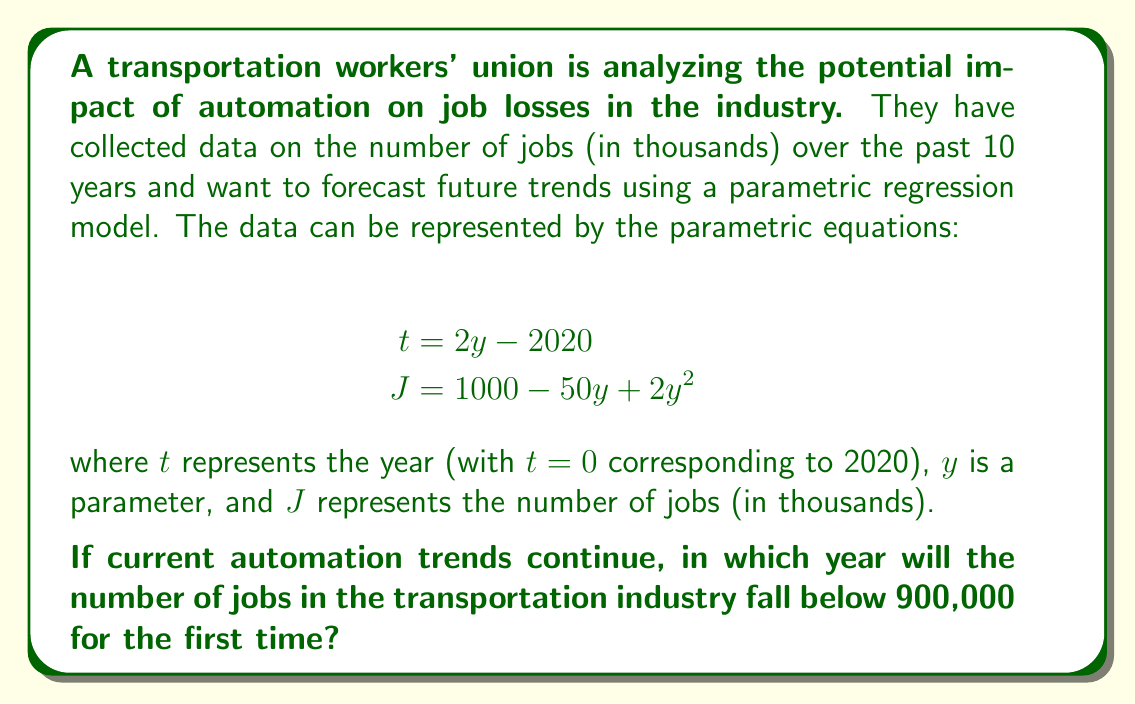Give your solution to this math problem. Let's approach this step-by-step:

1) We need to find when $J < 900$. So, we set up the inequality:
   $$1000 - 50y + 2y^2 < 900$$

2) Rearrange the inequality:
   $$2y^2 - 50y + 100 < 0$$

3) This is a quadratic inequality. To solve it, we first find the roots of the equation:
   $$2y^2 - 50y + 100 = 0$$

4) Using the quadratic formula $y = \frac{-b \pm \sqrt{b^2 - 4ac}}{2a}$, we get:
   $$y = \frac{50 \pm \sqrt{2500 - 800}}{4} = \frac{50 \pm \sqrt{1700}}{4}$$

5) Simplifying:
   $$y \approx 22.09 \text{ or } 2.91$$

6) The inequality is satisfied when $y$ is between these two values. Since $y$ represents time progressing forward, we're interested in the larger value.

7) When $y \approx 22.09$, $J$ will be just below 900,000.

8) To find the corresponding year, we use the equation for $t$:
   $$t = 2y - 2020$$
   $$t = 2(22.09) - 2020 \approx 44.18 - 2020 \approx -1975.82$$

9) Since $t=0$ corresponds to 2020, we add 2020 to our $t$ value:
   $$2020 + (-1975.82) \approx 2044.18$$

Therefore, if current trends continue, the number of jobs will fall below 900,000 for the first time in early 2044.
Answer: 2044 